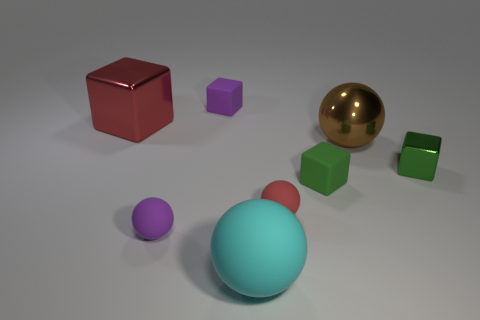Add 1 metal spheres. How many objects exist? 9 Subtract all big blocks. How many blocks are left? 3 Subtract all green cubes. How many cubes are left? 2 Add 3 brown rubber spheres. How many brown rubber spheres exist? 3 Subtract 1 brown balls. How many objects are left? 7 Subtract 2 cubes. How many cubes are left? 2 Subtract all cyan blocks. Subtract all gray balls. How many blocks are left? 4 Subtract all brown cubes. How many red spheres are left? 1 Subtract all brown rubber cylinders. Subtract all small green objects. How many objects are left? 6 Add 7 big red metallic blocks. How many big red metallic blocks are left? 8 